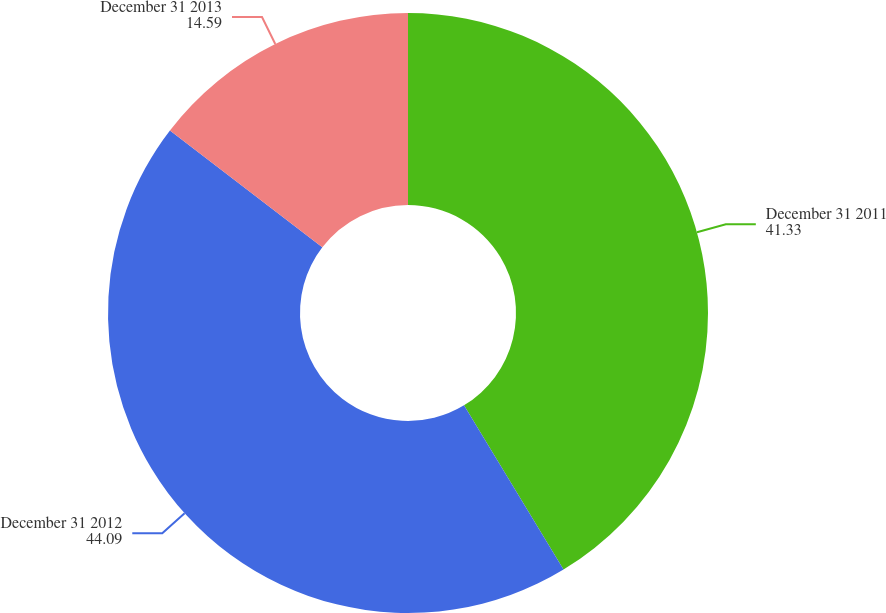Convert chart. <chart><loc_0><loc_0><loc_500><loc_500><pie_chart><fcel>December 31 2011<fcel>December 31 2012<fcel>December 31 2013<nl><fcel>41.33%<fcel>44.09%<fcel>14.59%<nl></chart> 